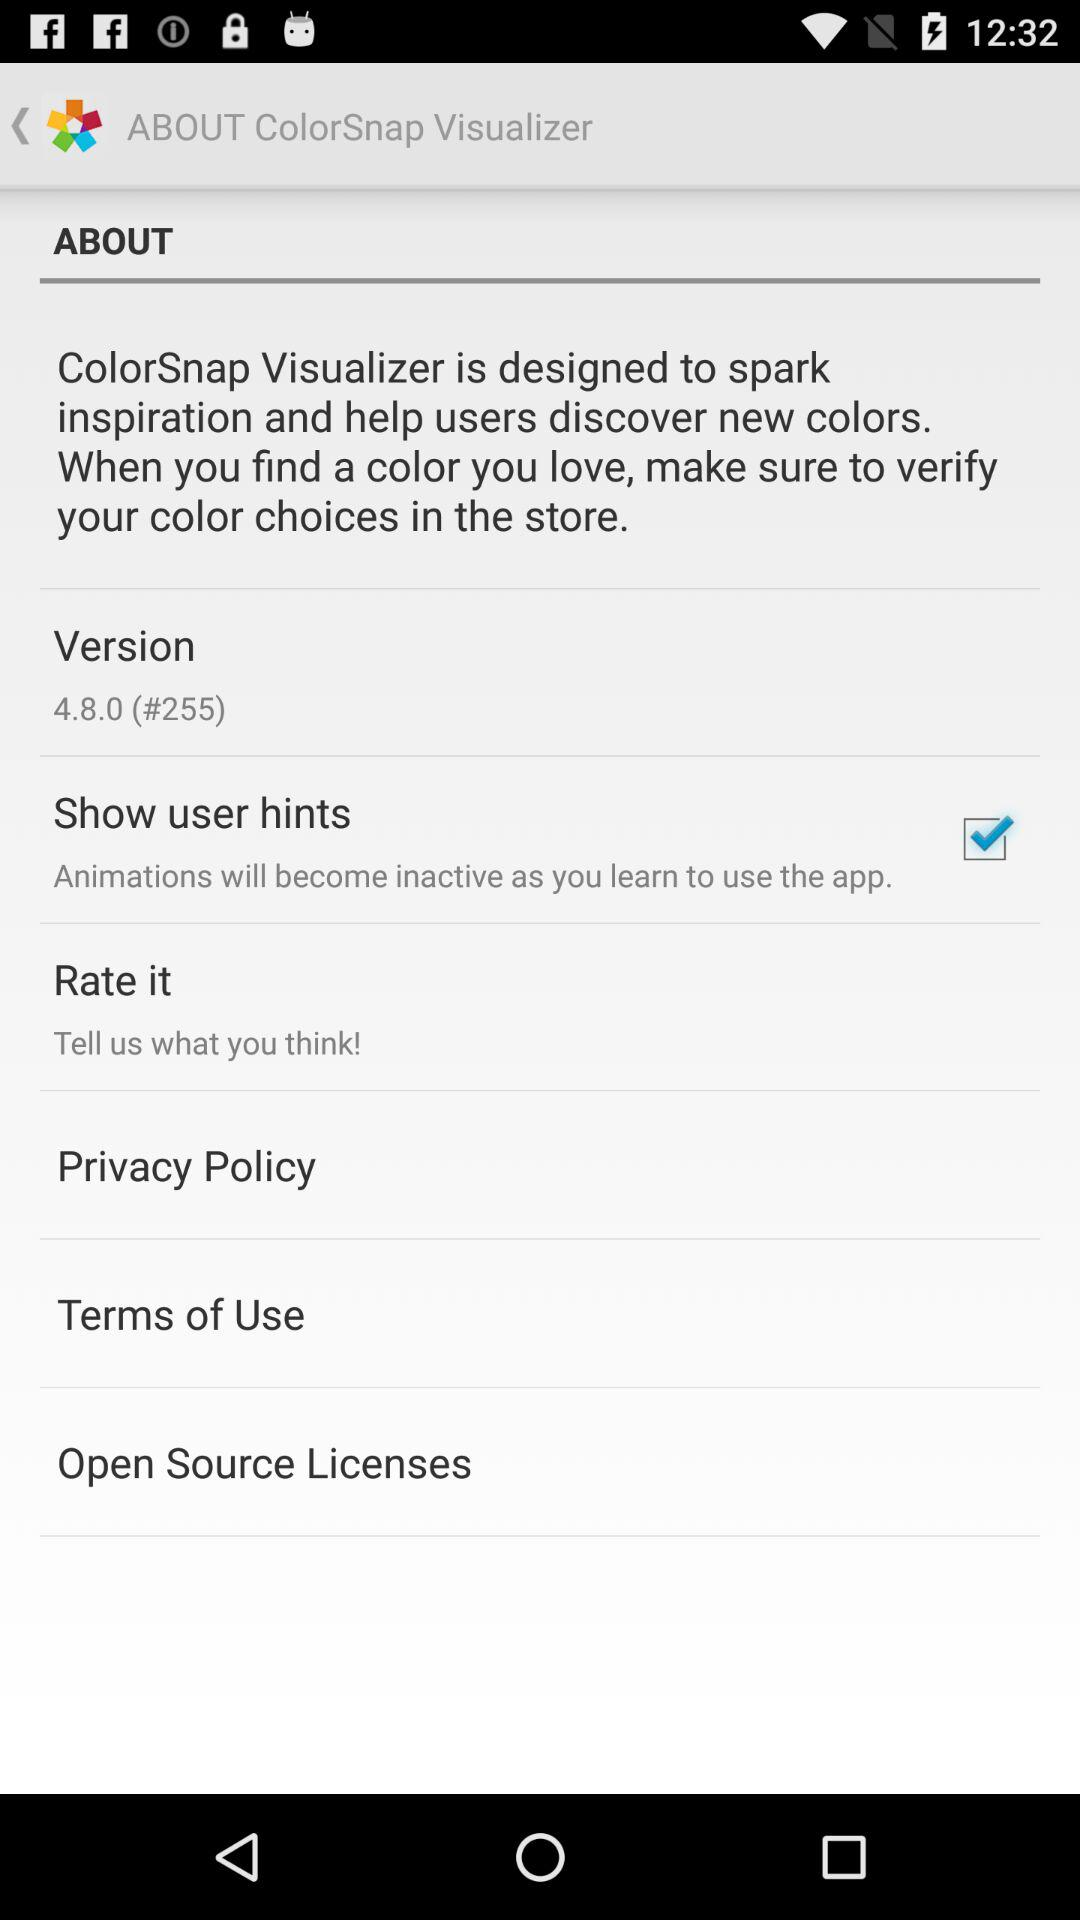What option is checked? The checked option is "Show user hints". 